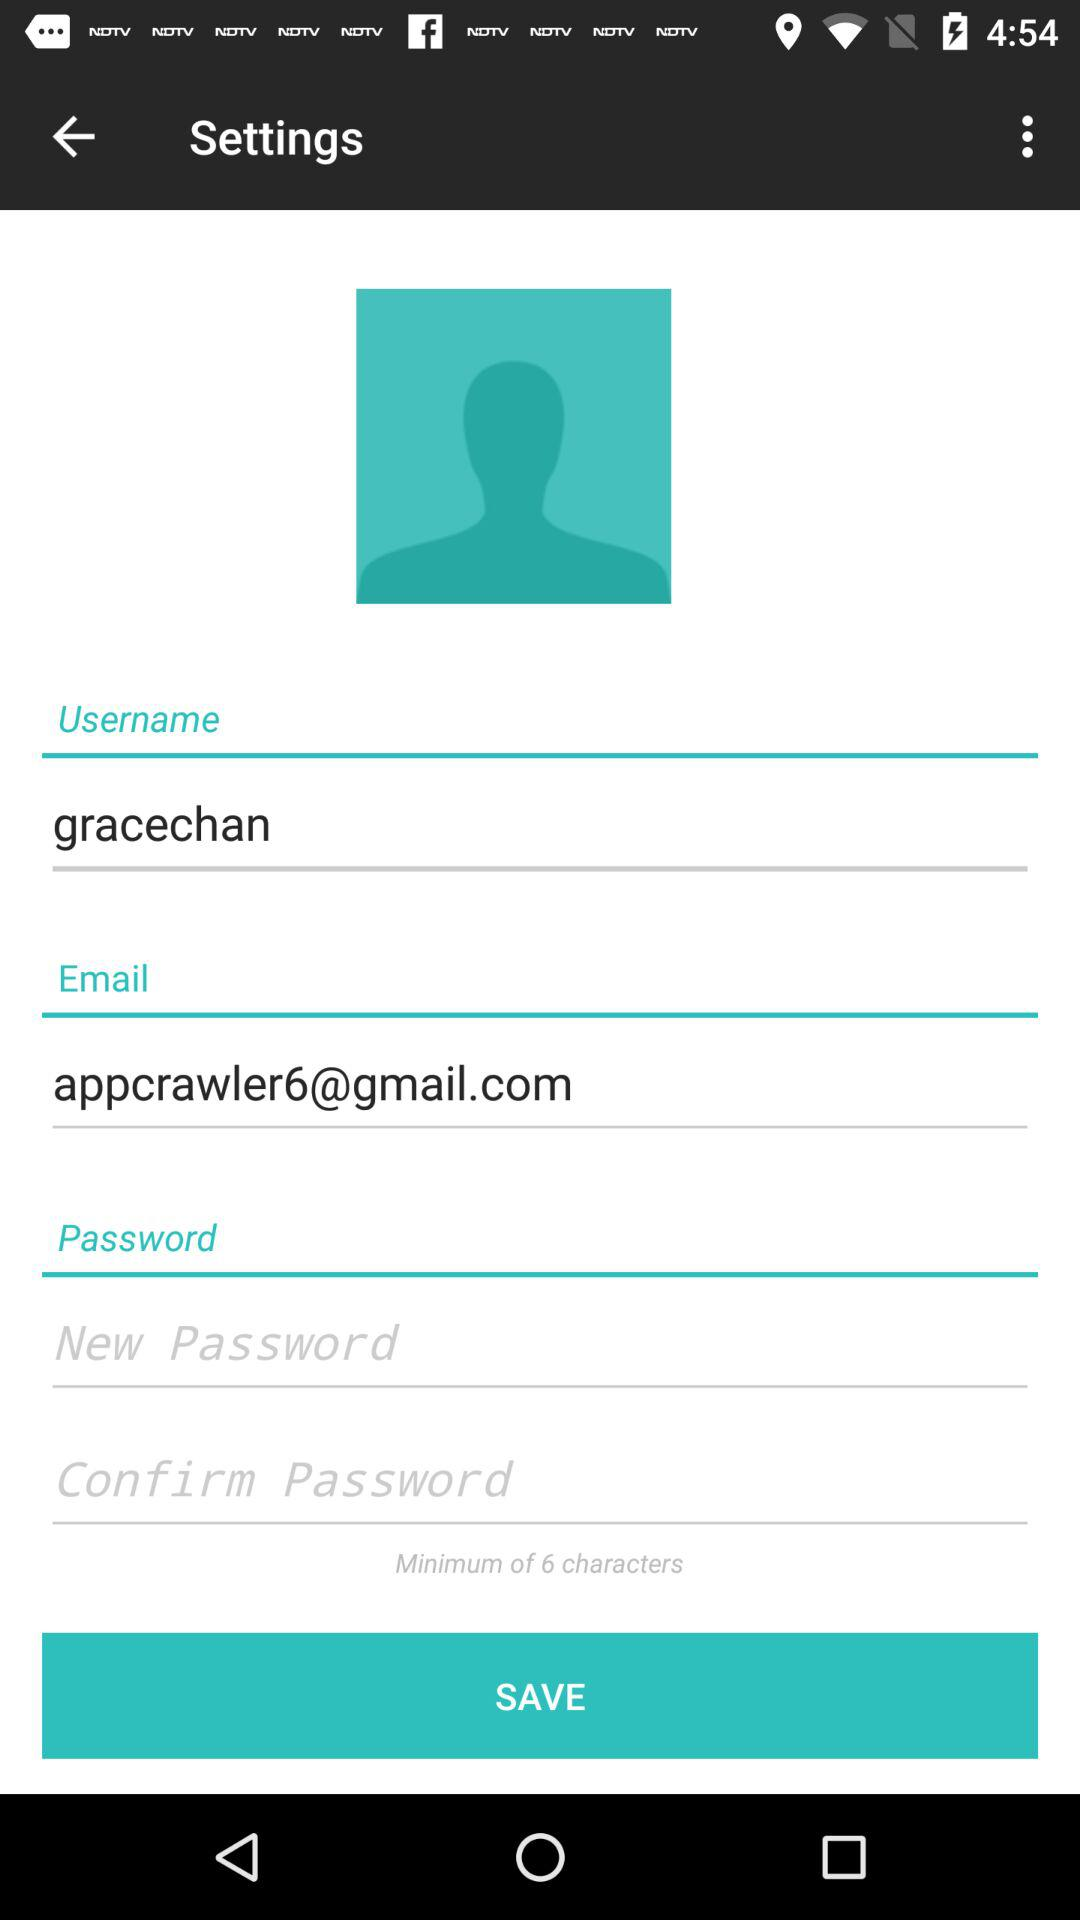What is the email address? The email address is appcrawler6@gmail.com. 